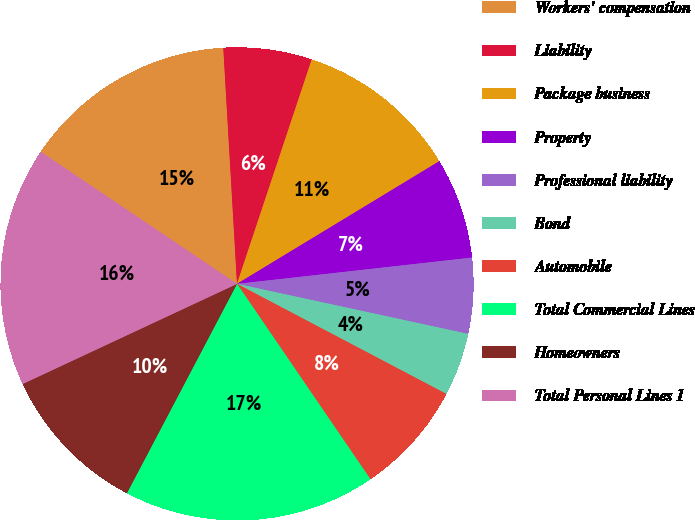Convert chart. <chart><loc_0><loc_0><loc_500><loc_500><pie_chart><fcel>Workers' compensation<fcel>Liability<fcel>Package business<fcel>Property<fcel>Professional liability<fcel>Bond<fcel>Automobile<fcel>Total Commercial Lines<fcel>Homeowners<fcel>Total Personal Lines 1<nl><fcel>14.65%<fcel>6.04%<fcel>11.21%<fcel>6.9%<fcel>5.17%<fcel>4.31%<fcel>7.76%<fcel>17.24%<fcel>10.34%<fcel>16.38%<nl></chart> 